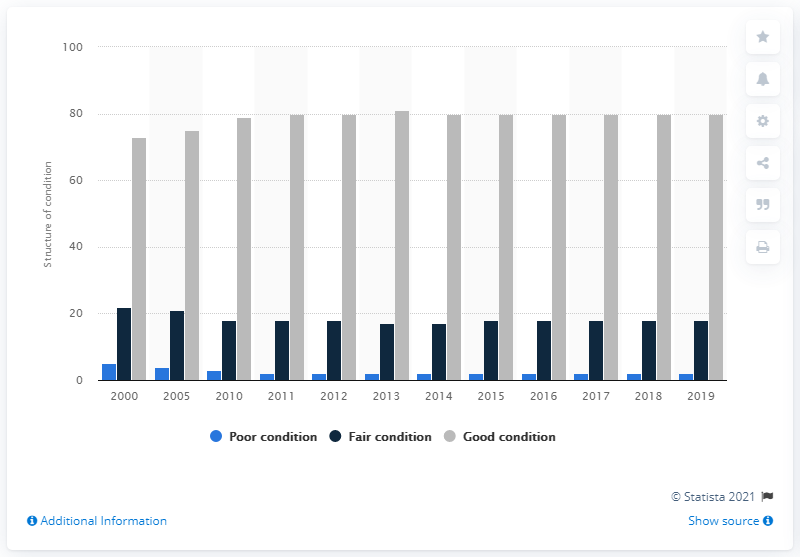Specify some key components in this picture. In 2019, 80% of airport runway pavements were found to be in good condition. This is an improvement from the previous year, indicating that airport operators are taking steps to maintain and improve the safety of runway pavements. 